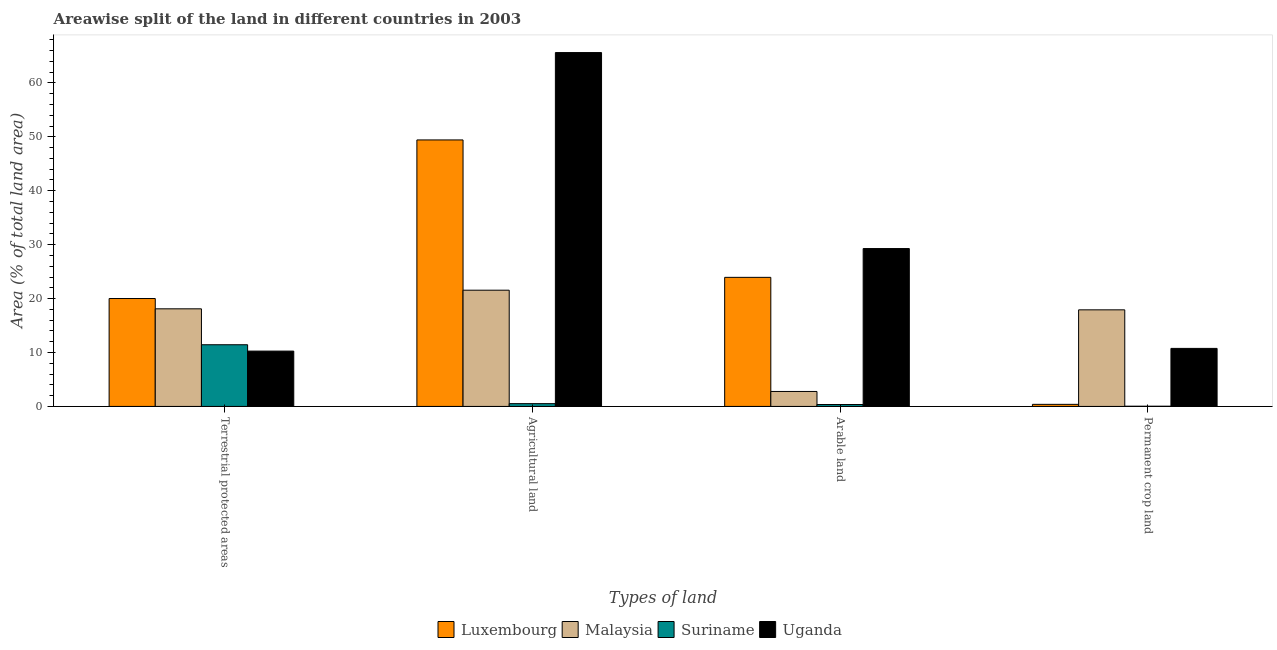How many different coloured bars are there?
Keep it short and to the point. 4. Are the number of bars per tick equal to the number of legend labels?
Your answer should be very brief. Yes. Are the number of bars on each tick of the X-axis equal?
Provide a succinct answer. Yes. How many bars are there on the 4th tick from the left?
Ensure brevity in your answer.  4. What is the label of the 1st group of bars from the left?
Your response must be concise. Terrestrial protected areas. What is the percentage of area under permanent crop land in Malaysia?
Your answer should be very brief. 17.91. Across all countries, what is the maximum percentage of land under terrestrial protection?
Provide a succinct answer. 20.01. Across all countries, what is the minimum percentage of area under agricultural land?
Your response must be concise. 0.52. In which country was the percentage of land under terrestrial protection maximum?
Make the answer very short. Luxembourg. In which country was the percentage of area under permanent crop land minimum?
Your answer should be compact. Suriname. What is the total percentage of area under agricultural land in the graph?
Your answer should be compact. 137.11. What is the difference between the percentage of area under arable land in Suriname and that in Malaysia?
Offer a very short reply. -2.42. What is the difference between the percentage of area under agricultural land in Luxembourg and the percentage of land under terrestrial protection in Uganda?
Make the answer very short. 39.16. What is the average percentage of area under permanent crop land per country?
Your answer should be compact. 7.27. What is the difference between the percentage of area under permanent crop land and percentage of area under agricultural land in Malaysia?
Your answer should be very brief. -3.64. What is the ratio of the percentage of area under agricultural land in Uganda to that in Luxembourg?
Make the answer very short. 1.33. Is the difference between the percentage of area under agricultural land in Uganda and Suriname greater than the difference between the percentage of land under terrestrial protection in Uganda and Suriname?
Your response must be concise. Yes. What is the difference between the highest and the second highest percentage of area under agricultural land?
Provide a short and direct response. 16.2. What is the difference between the highest and the lowest percentage of area under arable land?
Offer a very short reply. 28.93. Is the sum of the percentage of area under arable land in Uganda and Luxembourg greater than the maximum percentage of area under agricultural land across all countries?
Your answer should be very brief. No. Is it the case that in every country, the sum of the percentage of area under permanent crop land and percentage of land under terrestrial protection is greater than the sum of percentage of area under agricultural land and percentage of area under arable land?
Your answer should be compact. No. What does the 2nd bar from the left in Permanent crop land represents?
Make the answer very short. Malaysia. What does the 4th bar from the right in Agricultural land represents?
Keep it short and to the point. Luxembourg. What is the difference between two consecutive major ticks on the Y-axis?
Make the answer very short. 10. Where does the legend appear in the graph?
Your response must be concise. Bottom center. How many legend labels are there?
Your answer should be compact. 4. How are the legend labels stacked?
Provide a succinct answer. Horizontal. What is the title of the graph?
Your response must be concise. Areawise split of the land in different countries in 2003. What is the label or title of the X-axis?
Offer a terse response. Types of land. What is the label or title of the Y-axis?
Make the answer very short. Area (% of total land area). What is the Area (% of total land area) of Luxembourg in Terrestrial protected areas?
Give a very brief answer. 20.01. What is the Area (% of total land area) in Malaysia in Terrestrial protected areas?
Your answer should be very brief. 18.1. What is the Area (% of total land area) of Suriname in Terrestrial protected areas?
Your answer should be compact. 11.44. What is the Area (% of total land area) of Uganda in Terrestrial protected areas?
Ensure brevity in your answer.  10.26. What is the Area (% of total land area) of Luxembourg in Agricultural land?
Ensure brevity in your answer.  49.42. What is the Area (% of total land area) in Malaysia in Agricultural land?
Provide a short and direct response. 21.56. What is the Area (% of total land area) of Suriname in Agricultural land?
Offer a very short reply. 0.52. What is the Area (% of total land area) in Uganda in Agricultural land?
Make the answer very short. 65.62. What is the Area (% of total land area) of Luxembourg in Arable land?
Your answer should be very brief. 23.94. What is the Area (% of total land area) in Malaysia in Arable land?
Make the answer very short. 2.78. What is the Area (% of total land area) of Suriname in Arable land?
Offer a very short reply. 0.35. What is the Area (% of total land area) of Uganda in Arable land?
Your answer should be compact. 29.28. What is the Area (% of total land area) in Luxembourg in Permanent crop land?
Offer a very short reply. 0.39. What is the Area (% of total land area) in Malaysia in Permanent crop land?
Offer a terse response. 17.91. What is the Area (% of total land area) of Suriname in Permanent crop land?
Provide a short and direct response. 0.04. What is the Area (% of total land area) in Uganda in Permanent crop land?
Provide a succinct answer. 10.76. Across all Types of land, what is the maximum Area (% of total land area) in Luxembourg?
Your answer should be compact. 49.42. Across all Types of land, what is the maximum Area (% of total land area) in Malaysia?
Your answer should be very brief. 21.56. Across all Types of land, what is the maximum Area (% of total land area) in Suriname?
Give a very brief answer. 11.44. Across all Types of land, what is the maximum Area (% of total land area) in Uganda?
Ensure brevity in your answer.  65.62. Across all Types of land, what is the minimum Area (% of total land area) in Luxembourg?
Ensure brevity in your answer.  0.39. Across all Types of land, what is the minimum Area (% of total land area) in Malaysia?
Make the answer very short. 2.78. Across all Types of land, what is the minimum Area (% of total land area) in Suriname?
Offer a terse response. 0.04. Across all Types of land, what is the minimum Area (% of total land area) of Uganda?
Provide a short and direct response. 10.26. What is the total Area (% of total land area) in Luxembourg in the graph?
Ensure brevity in your answer.  93.76. What is the total Area (% of total land area) of Malaysia in the graph?
Your response must be concise. 60.34. What is the total Area (% of total land area) of Suriname in the graph?
Your response must be concise. 12.35. What is the total Area (% of total land area) of Uganda in the graph?
Your response must be concise. 115.92. What is the difference between the Area (% of total land area) in Luxembourg in Terrestrial protected areas and that in Agricultural land?
Your answer should be very brief. -29.41. What is the difference between the Area (% of total land area) of Malaysia in Terrestrial protected areas and that in Agricultural land?
Keep it short and to the point. -3.45. What is the difference between the Area (% of total land area) in Suriname in Terrestrial protected areas and that in Agricultural land?
Offer a terse response. 10.92. What is the difference between the Area (% of total land area) in Uganda in Terrestrial protected areas and that in Agricultural land?
Offer a terse response. -55.36. What is the difference between the Area (% of total land area) in Luxembourg in Terrestrial protected areas and that in Arable land?
Your answer should be compact. -3.93. What is the difference between the Area (% of total land area) in Malaysia in Terrestrial protected areas and that in Arable land?
Provide a succinct answer. 15.33. What is the difference between the Area (% of total land area) in Suriname in Terrestrial protected areas and that in Arable land?
Make the answer very short. 11.09. What is the difference between the Area (% of total land area) in Uganda in Terrestrial protected areas and that in Arable land?
Keep it short and to the point. -19.02. What is the difference between the Area (% of total land area) of Luxembourg in Terrestrial protected areas and that in Permanent crop land?
Provide a succinct answer. 19.63. What is the difference between the Area (% of total land area) in Malaysia in Terrestrial protected areas and that in Permanent crop land?
Your answer should be compact. 0.19. What is the difference between the Area (% of total land area) in Suriname in Terrestrial protected areas and that in Permanent crop land?
Ensure brevity in your answer.  11.4. What is the difference between the Area (% of total land area) of Uganda in Terrestrial protected areas and that in Permanent crop land?
Provide a short and direct response. -0.5. What is the difference between the Area (% of total land area) of Luxembourg in Agricultural land and that in Arable land?
Ensure brevity in your answer.  25.48. What is the difference between the Area (% of total land area) in Malaysia in Agricultural land and that in Arable land?
Make the answer very short. 18.78. What is the difference between the Area (% of total land area) in Suriname in Agricultural land and that in Arable land?
Give a very brief answer. 0.16. What is the difference between the Area (% of total land area) in Uganda in Agricultural land and that in Arable land?
Your response must be concise. 36.34. What is the difference between the Area (% of total land area) in Luxembourg in Agricultural land and that in Permanent crop land?
Give a very brief answer. 49.03. What is the difference between the Area (% of total land area) in Malaysia in Agricultural land and that in Permanent crop land?
Your response must be concise. 3.64. What is the difference between the Area (% of total land area) in Suriname in Agricultural land and that in Permanent crop land?
Ensure brevity in your answer.  0.48. What is the difference between the Area (% of total land area) in Uganda in Agricultural land and that in Permanent crop land?
Make the answer very short. 54.86. What is the difference between the Area (% of total land area) of Luxembourg in Arable land and that in Permanent crop land?
Make the answer very short. 23.55. What is the difference between the Area (% of total land area) in Malaysia in Arable land and that in Permanent crop land?
Your answer should be very brief. -15.14. What is the difference between the Area (% of total land area) in Suriname in Arable land and that in Permanent crop land?
Your answer should be compact. 0.31. What is the difference between the Area (% of total land area) of Uganda in Arable land and that in Permanent crop land?
Give a very brief answer. 18.52. What is the difference between the Area (% of total land area) in Luxembourg in Terrestrial protected areas and the Area (% of total land area) in Malaysia in Agricultural land?
Your response must be concise. -1.54. What is the difference between the Area (% of total land area) in Luxembourg in Terrestrial protected areas and the Area (% of total land area) in Suriname in Agricultural land?
Offer a very short reply. 19.5. What is the difference between the Area (% of total land area) in Luxembourg in Terrestrial protected areas and the Area (% of total land area) in Uganda in Agricultural land?
Your answer should be compact. -45.61. What is the difference between the Area (% of total land area) of Malaysia in Terrestrial protected areas and the Area (% of total land area) of Suriname in Agricultural land?
Give a very brief answer. 17.59. What is the difference between the Area (% of total land area) of Malaysia in Terrestrial protected areas and the Area (% of total land area) of Uganda in Agricultural land?
Your answer should be very brief. -47.52. What is the difference between the Area (% of total land area) in Suriname in Terrestrial protected areas and the Area (% of total land area) in Uganda in Agricultural land?
Provide a short and direct response. -54.18. What is the difference between the Area (% of total land area) of Luxembourg in Terrestrial protected areas and the Area (% of total land area) of Malaysia in Arable land?
Give a very brief answer. 17.24. What is the difference between the Area (% of total land area) in Luxembourg in Terrestrial protected areas and the Area (% of total land area) in Suriname in Arable land?
Provide a succinct answer. 19.66. What is the difference between the Area (% of total land area) in Luxembourg in Terrestrial protected areas and the Area (% of total land area) in Uganda in Arable land?
Offer a very short reply. -9.27. What is the difference between the Area (% of total land area) of Malaysia in Terrestrial protected areas and the Area (% of total land area) of Suriname in Arable land?
Make the answer very short. 17.75. What is the difference between the Area (% of total land area) in Malaysia in Terrestrial protected areas and the Area (% of total land area) in Uganda in Arable land?
Your answer should be compact. -11.18. What is the difference between the Area (% of total land area) of Suriname in Terrestrial protected areas and the Area (% of total land area) of Uganda in Arable land?
Offer a terse response. -17.84. What is the difference between the Area (% of total land area) of Luxembourg in Terrestrial protected areas and the Area (% of total land area) of Malaysia in Permanent crop land?
Keep it short and to the point. 2.1. What is the difference between the Area (% of total land area) of Luxembourg in Terrestrial protected areas and the Area (% of total land area) of Suriname in Permanent crop land?
Give a very brief answer. 19.97. What is the difference between the Area (% of total land area) of Luxembourg in Terrestrial protected areas and the Area (% of total land area) of Uganda in Permanent crop land?
Make the answer very short. 9.25. What is the difference between the Area (% of total land area) of Malaysia in Terrestrial protected areas and the Area (% of total land area) of Suriname in Permanent crop land?
Your answer should be very brief. 18.06. What is the difference between the Area (% of total land area) in Malaysia in Terrestrial protected areas and the Area (% of total land area) in Uganda in Permanent crop land?
Ensure brevity in your answer.  7.34. What is the difference between the Area (% of total land area) of Suriname in Terrestrial protected areas and the Area (% of total land area) of Uganda in Permanent crop land?
Give a very brief answer. 0.68. What is the difference between the Area (% of total land area) of Luxembourg in Agricultural land and the Area (% of total land area) of Malaysia in Arable land?
Provide a short and direct response. 46.65. What is the difference between the Area (% of total land area) in Luxembourg in Agricultural land and the Area (% of total land area) in Suriname in Arable land?
Make the answer very short. 49.07. What is the difference between the Area (% of total land area) of Luxembourg in Agricultural land and the Area (% of total land area) of Uganda in Arable land?
Your answer should be very brief. 20.14. What is the difference between the Area (% of total land area) in Malaysia in Agricultural land and the Area (% of total land area) in Suriname in Arable land?
Keep it short and to the point. 21.2. What is the difference between the Area (% of total land area) of Malaysia in Agricultural land and the Area (% of total land area) of Uganda in Arable land?
Offer a very short reply. -7.72. What is the difference between the Area (% of total land area) in Suriname in Agricultural land and the Area (% of total land area) in Uganda in Arable land?
Give a very brief answer. -28.76. What is the difference between the Area (% of total land area) of Luxembourg in Agricultural land and the Area (% of total land area) of Malaysia in Permanent crop land?
Provide a short and direct response. 31.51. What is the difference between the Area (% of total land area) of Luxembourg in Agricultural land and the Area (% of total land area) of Suriname in Permanent crop land?
Give a very brief answer. 49.38. What is the difference between the Area (% of total land area) of Luxembourg in Agricultural land and the Area (% of total land area) of Uganda in Permanent crop land?
Make the answer very short. 38.66. What is the difference between the Area (% of total land area) in Malaysia in Agricultural land and the Area (% of total land area) in Suriname in Permanent crop land?
Provide a short and direct response. 21.52. What is the difference between the Area (% of total land area) in Malaysia in Agricultural land and the Area (% of total land area) in Uganda in Permanent crop land?
Keep it short and to the point. 10.79. What is the difference between the Area (% of total land area) of Suriname in Agricultural land and the Area (% of total land area) of Uganda in Permanent crop land?
Keep it short and to the point. -10.24. What is the difference between the Area (% of total land area) in Luxembourg in Arable land and the Area (% of total land area) in Malaysia in Permanent crop land?
Your answer should be very brief. 6.03. What is the difference between the Area (% of total land area) in Luxembourg in Arable land and the Area (% of total land area) in Suriname in Permanent crop land?
Keep it short and to the point. 23.9. What is the difference between the Area (% of total land area) in Luxembourg in Arable land and the Area (% of total land area) in Uganda in Permanent crop land?
Make the answer very short. 13.18. What is the difference between the Area (% of total land area) of Malaysia in Arable land and the Area (% of total land area) of Suriname in Permanent crop land?
Provide a short and direct response. 2.74. What is the difference between the Area (% of total land area) of Malaysia in Arable land and the Area (% of total land area) of Uganda in Permanent crop land?
Offer a very short reply. -7.98. What is the difference between the Area (% of total land area) in Suriname in Arable land and the Area (% of total land area) in Uganda in Permanent crop land?
Ensure brevity in your answer.  -10.41. What is the average Area (% of total land area) of Luxembourg per Types of land?
Provide a succinct answer. 23.44. What is the average Area (% of total land area) in Malaysia per Types of land?
Keep it short and to the point. 15.09. What is the average Area (% of total land area) in Suriname per Types of land?
Give a very brief answer. 3.09. What is the average Area (% of total land area) of Uganda per Types of land?
Provide a succinct answer. 28.98. What is the difference between the Area (% of total land area) of Luxembourg and Area (% of total land area) of Malaysia in Terrestrial protected areas?
Offer a very short reply. 1.91. What is the difference between the Area (% of total land area) of Luxembourg and Area (% of total land area) of Suriname in Terrestrial protected areas?
Give a very brief answer. 8.57. What is the difference between the Area (% of total land area) of Luxembourg and Area (% of total land area) of Uganda in Terrestrial protected areas?
Make the answer very short. 9.75. What is the difference between the Area (% of total land area) of Malaysia and Area (% of total land area) of Suriname in Terrestrial protected areas?
Provide a short and direct response. 6.66. What is the difference between the Area (% of total land area) of Malaysia and Area (% of total land area) of Uganda in Terrestrial protected areas?
Provide a succinct answer. 7.84. What is the difference between the Area (% of total land area) in Suriname and Area (% of total land area) in Uganda in Terrestrial protected areas?
Ensure brevity in your answer.  1.18. What is the difference between the Area (% of total land area) in Luxembourg and Area (% of total land area) in Malaysia in Agricultural land?
Make the answer very short. 27.87. What is the difference between the Area (% of total land area) of Luxembourg and Area (% of total land area) of Suriname in Agricultural land?
Your answer should be compact. 48.9. What is the difference between the Area (% of total land area) in Luxembourg and Area (% of total land area) in Uganda in Agricultural land?
Offer a terse response. -16.2. What is the difference between the Area (% of total land area) in Malaysia and Area (% of total land area) in Suriname in Agricultural land?
Keep it short and to the point. 21.04. What is the difference between the Area (% of total land area) in Malaysia and Area (% of total land area) in Uganda in Agricultural land?
Your response must be concise. -44.07. What is the difference between the Area (% of total land area) in Suriname and Area (% of total land area) in Uganda in Agricultural land?
Your answer should be very brief. -65.11. What is the difference between the Area (% of total land area) in Luxembourg and Area (% of total land area) in Malaysia in Arable land?
Ensure brevity in your answer.  21.16. What is the difference between the Area (% of total land area) in Luxembourg and Area (% of total land area) in Suriname in Arable land?
Provide a succinct answer. 23.59. What is the difference between the Area (% of total land area) of Luxembourg and Area (% of total land area) of Uganda in Arable land?
Provide a succinct answer. -5.34. What is the difference between the Area (% of total land area) of Malaysia and Area (% of total land area) of Suriname in Arable land?
Keep it short and to the point. 2.42. What is the difference between the Area (% of total land area) in Malaysia and Area (% of total land area) in Uganda in Arable land?
Your response must be concise. -26.5. What is the difference between the Area (% of total land area) in Suriname and Area (% of total land area) in Uganda in Arable land?
Your answer should be compact. -28.93. What is the difference between the Area (% of total land area) in Luxembourg and Area (% of total land area) in Malaysia in Permanent crop land?
Provide a succinct answer. -17.53. What is the difference between the Area (% of total land area) of Luxembourg and Area (% of total land area) of Suriname in Permanent crop land?
Keep it short and to the point. 0.35. What is the difference between the Area (% of total land area) of Luxembourg and Area (% of total land area) of Uganda in Permanent crop land?
Make the answer very short. -10.37. What is the difference between the Area (% of total land area) of Malaysia and Area (% of total land area) of Suriname in Permanent crop land?
Ensure brevity in your answer.  17.87. What is the difference between the Area (% of total land area) in Malaysia and Area (% of total land area) in Uganda in Permanent crop land?
Your answer should be very brief. 7.15. What is the difference between the Area (% of total land area) in Suriname and Area (% of total land area) in Uganda in Permanent crop land?
Offer a very short reply. -10.72. What is the ratio of the Area (% of total land area) in Luxembourg in Terrestrial protected areas to that in Agricultural land?
Your answer should be compact. 0.4. What is the ratio of the Area (% of total land area) in Malaysia in Terrestrial protected areas to that in Agricultural land?
Make the answer very short. 0.84. What is the ratio of the Area (% of total land area) in Suriname in Terrestrial protected areas to that in Agricultural land?
Give a very brief answer. 22.17. What is the ratio of the Area (% of total land area) in Uganda in Terrestrial protected areas to that in Agricultural land?
Make the answer very short. 0.16. What is the ratio of the Area (% of total land area) of Luxembourg in Terrestrial protected areas to that in Arable land?
Give a very brief answer. 0.84. What is the ratio of the Area (% of total land area) in Malaysia in Terrestrial protected areas to that in Arable land?
Your answer should be compact. 6.52. What is the ratio of the Area (% of total land area) of Suriname in Terrestrial protected areas to that in Arable land?
Ensure brevity in your answer.  32.45. What is the ratio of the Area (% of total land area) in Uganda in Terrestrial protected areas to that in Arable land?
Your response must be concise. 0.35. What is the ratio of the Area (% of total land area) in Luxembourg in Terrestrial protected areas to that in Permanent crop land?
Give a very brief answer. 51.83. What is the ratio of the Area (% of total land area) of Malaysia in Terrestrial protected areas to that in Permanent crop land?
Offer a terse response. 1.01. What is the ratio of the Area (% of total land area) of Suriname in Terrestrial protected areas to that in Permanent crop land?
Provide a succinct answer. 297.43. What is the ratio of the Area (% of total land area) of Uganda in Terrestrial protected areas to that in Permanent crop land?
Your answer should be very brief. 0.95. What is the ratio of the Area (% of total land area) of Luxembourg in Agricultural land to that in Arable land?
Keep it short and to the point. 2.06. What is the ratio of the Area (% of total land area) in Malaysia in Agricultural land to that in Arable land?
Your answer should be very brief. 7.77. What is the ratio of the Area (% of total land area) in Suriname in Agricultural land to that in Arable land?
Offer a terse response. 1.46. What is the ratio of the Area (% of total land area) in Uganda in Agricultural land to that in Arable land?
Your answer should be compact. 2.24. What is the ratio of the Area (% of total land area) in Luxembourg in Agricultural land to that in Permanent crop land?
Your answer should be very brief. 128. What is the ratio of the Area (% of total land area) of Malaysia in Agricultural land to that in Permanent crop land?
Provide a short and direct response. 1.2. What is the ratio of the Area (% of total land area) in Suriname in Agricultural land to that in Permanent crop land?
Offer a terse response. 13.42. What is the ratio of the Area (% of total land area) in Uganda in Agricultural land to that in Permanent crop land?
Offer a very short reply. 6.1. What is the ratio of the Area (% of total land area) of Malaysia in Arable land to that in Permanent crop land?
Your answer should be very brief. 0.15. What is the ratio of the Area (% of total land area) in Suriname in Arable land to that in Permanent crop land?
Provide a succinct answer. 9.17. What is the ratio of the Area (% of total land area) in Uganda in Arable land to that in Permanent crop land?
Provide a succinct answer. 2.72. What is the difference between the highest and the second highest Area (% of total land area) in Luxembourg?
Provide a succinct answer. 25.48. What is the difference between the highest and the second highest Area (% of total land area) of Malaysia?
Provide a succinct answer. 3.45. What is the difference between the highest and the second highest Area (% of total land area) of Suriname?
Offer a very short reply. 10.92. What is the difference between the highest and the second highest Area (% of total land area) in Uganda?
Your answer should be compact. 36.34. What is the difference between the highest and the lowest Area (% of total land area) in Luxembourg?
Your answer should be very brief. 49.03. What is the difference between the highest and the lowest Area (% of total land area) in Malaysia?
Ensure brevity in your answer.  18.78. What is the difference between the highest and the lowest Area (% of total land area) of Suriname?
Your answer should be very brief. 11.4. What is the difference between the highest and the lowest Area (% of total land area) of Uganda?
Ensure brevity in your answer.  55.36. 